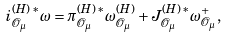<formula> <loc_0><loc_0><loc_500><loc_500>i _ { \mathcal { O } _ { \mu } } ^ { ( H ) \, * } \omega = \pi _ { \mathcal { O } _ { \mu } } ^ { ( H ) \, * } \omega _ { \mathcal { O } _ { \mu } } ^ { ( H ) } + J _ { \mathcal { O } _ { \mu } } ^ { ( H ) \, \ast } \omega _ { \mathcal { O } _ { \mu } } ^ { + } ,</formula> 